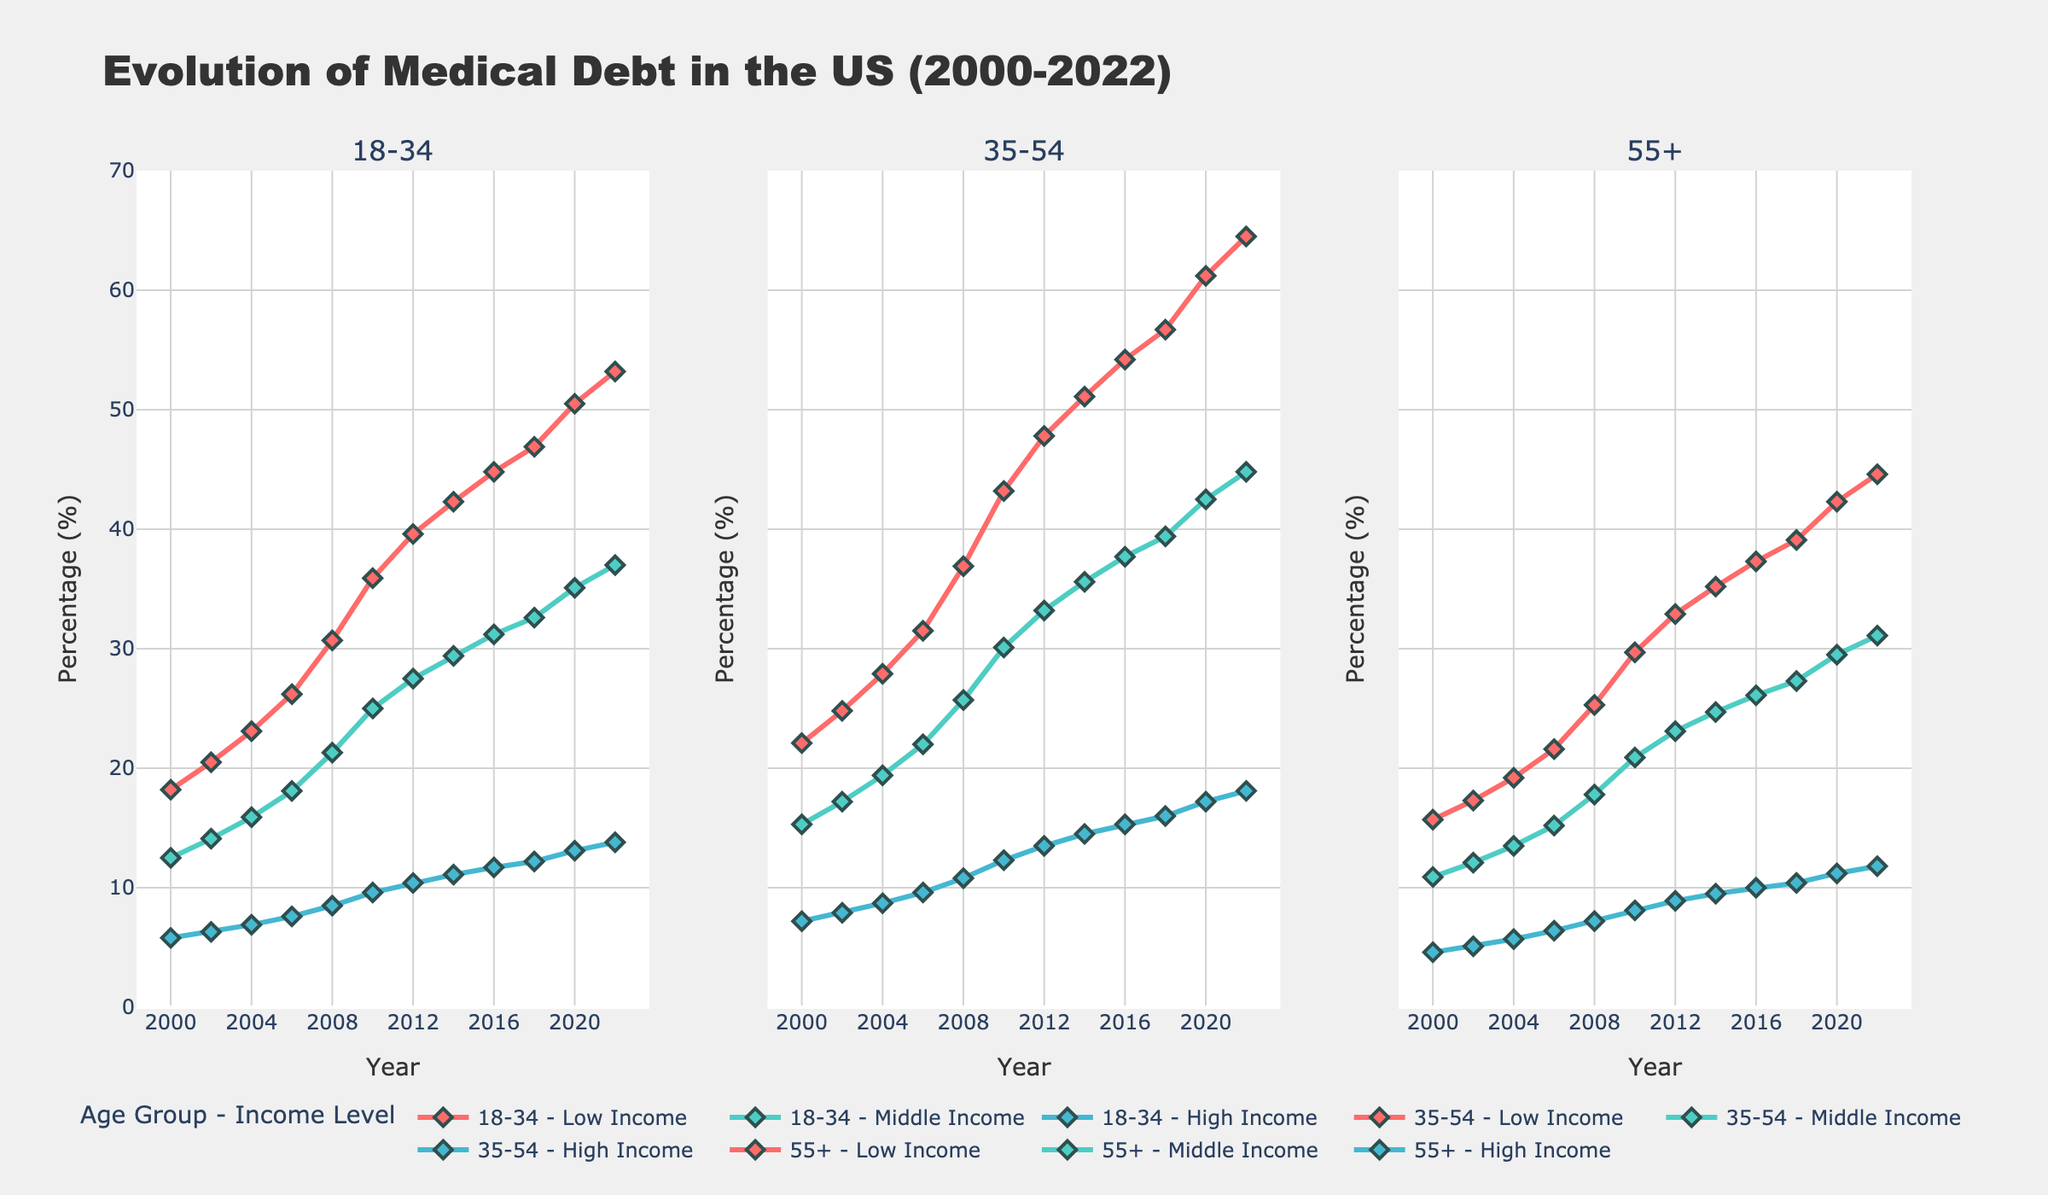What general trend can be observed for the medical debt of the 18-34 age group across all income levels from 2000 to 2022? The line chart shows that the medical debt percentages for the 18-34 age group across all income levels have increased steadily from 2000 to 2022.
Answer: Increasing trend Between which years did the 35-54 Low Income group see the largest increase in medical debt percentage? By examining the steepest slopes in the chart, the largest increase for the 35-54 Low Income group occurred between 2008 and 2010.
Answer: 2008 to 2010 Which income level shows the lowest percentage of medical debt for the 55+ age group in 2022? Within the 55+ age group in 2022, the line representing 'High Income' has the lowest percentage among the income levels.
Answer: High Income How does the medical debt percentage in 2022 for the 18-34 Low Income group compare to the 35-54 Middle Income group? In 2022, the medical debt percentage for the 18-34 Low Income group is around 53.2%, while for the 35-54 Middle Income group it is around 44.8%.
Answer: 18-34 Low Income group is higher What is the difference in medical debt percentage between the 18-34 High Income group and the 18-34 Low Income group in 2020? In 2020, the medical debt percentage for the 18-34 High Income group is 13.1%, and for the 18-34 Low Income group it is 50.5%. The difference is 50.5% - 13.1%.
Answer: 37.4% Which income level in the 35-54 age group saw the least change in medical debt percentage from 2000 to 2022? By comparing the initial and final points, the 35-54 High Income group saw the least change, increasing from 7.2% to 18.1%, a 10.9% difference.
Answer: High Income From 2000 to 2022, which age group in the Low Income category consistently had the lowest percentage of medical debt? By comparing the lines representing Low Income across age groups, the 55+ age group consistently had the lowest percentages throughout 2000 to 2022.
Answer: 55+ Compare the medical debt percentages in 2006 across all age groups for the Middle Income levels. Which age group had the highest and what was the percentage? In 2006, for Middle Income levels, the 35-54 age group had the highest medical debt percentage at 22.0%.
Answer: 35-54 at 22.0% 